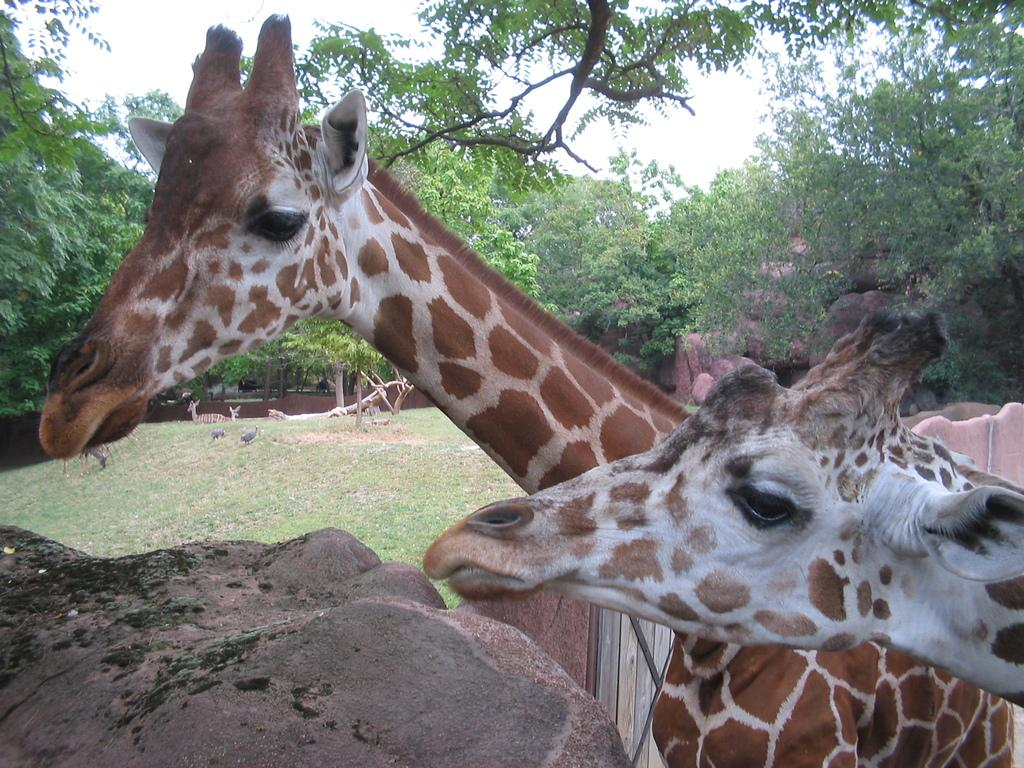What animals can be seen in the image? There are giraffes in the image. Where are the giraffes located in the image? The giraffes are near a rock and on the grass in the image. What type of vegetation is present in the image? There are trees in the image. What geological features can be seen in the image? There are rocks in the image. What type of silk is being used to make the giraffes' clothing in the image? There is no clothing or silk present in the image; the giraffes are depicted in their natural state. 